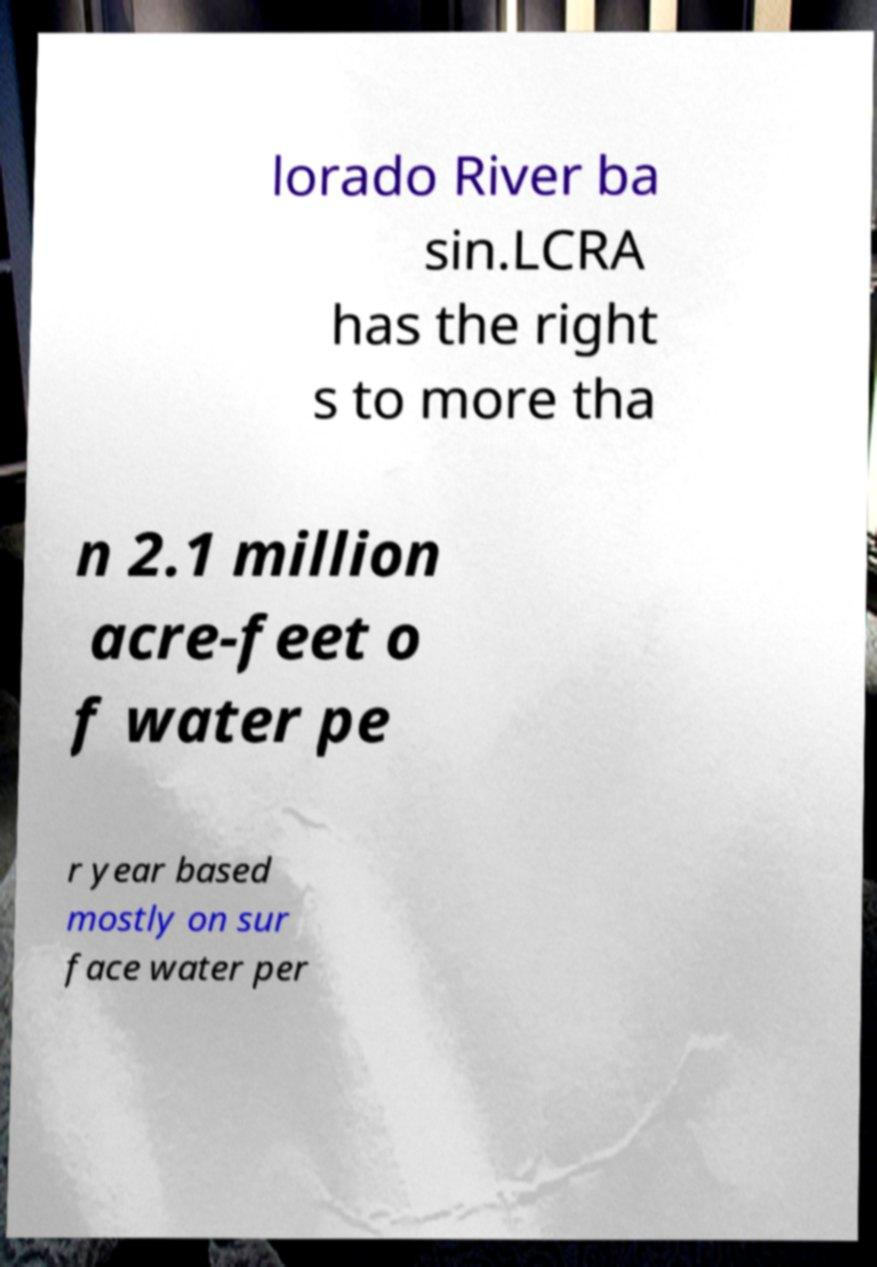Please identify and transcribe the text found in this image. lorado River ba sin.LCRA has the right s to more tha n 2.1 million acre-feet o f water pe r year based mostly on sur face water per 